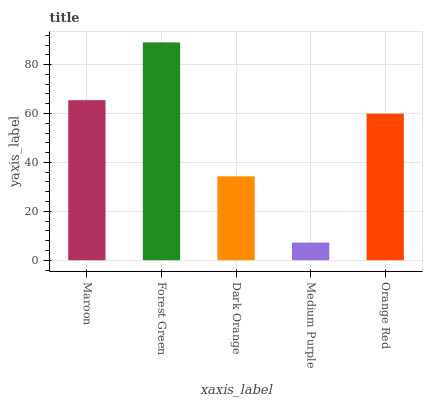Is Medium Purple the minimum?
Answer yes or no. Yes. Is Forest Green the maximum?
Answer yes or no. Yes. Is Dark Orange the minimum?
Answer yes or no. No. Is Dark Orange the maximum?
Answer yes or no. No. Is Forest Green greater than Dark Orange?
Answer yes or no. Yes. Is Dark Orange less than Forest Green?
Answer yes or no. Yes. Is Dark Orange greater than Forest Green?
Answer yes or no. No. Is Forest Green less than Dark Orange?
Answer yes or no. No. Is Orange Red the high median?
Answer yes or no. Yes. Is Orange Red the low median?
Answer yes or no. Yes. Is Medium Purple the high median?
Answer yes or no. No. Is Forest Green the low median?
Answer yes or no. No. 